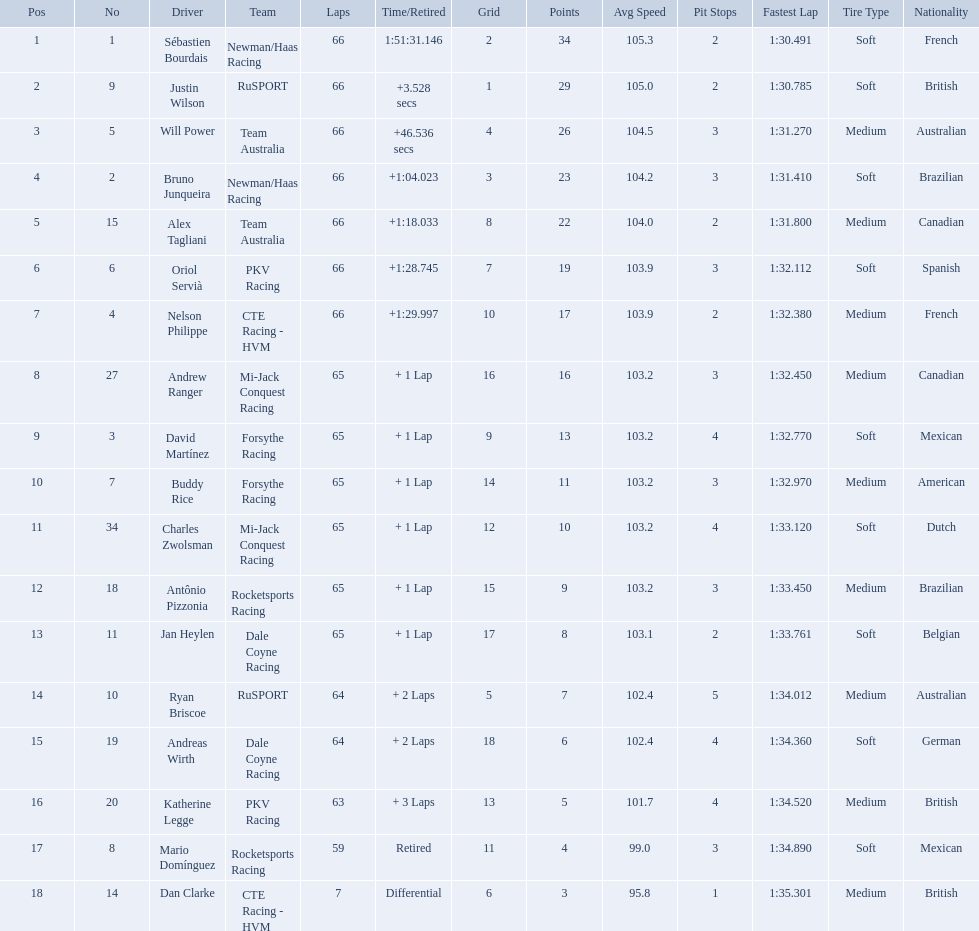What are the names of the drivers who were in position 14 through position 18? Ryan Briscoe, Andreas Wirth, Katherine Legge, Mario Domínguez, Dan Clarke. Of these , which ones didn't finish due to retired or differential? Mario Domínguez, Dan Clarke. Which one of the previous drivers retired? Mario Domínguez. Which of the drivers in question 2 had a differential? Dan Clarke. How many laps did oriol servia complete at the 2006 gran premio? 66. How many laps did katherine legge complete at the 2006 gran premio? 63. Between servia and legge, who completed more laps? Oriol Servià. Which people scored 29+ points? Sébastien Bourdais, Justin Wilson. Who scored higher? Sébastien Bourdais. What are the drivers numbers? 1, 9, 5, 2, 15, 6, 4, 27, 3, 7, 34, 18, 11, 10, 19, 20, 8, 14. Are there any who's number matches his position? Sébastien Bourdais, Oriol Servià. Of those two who has the highest position? Sébastien Bourdais. Who are the drivers? Sébastien Bourdais, Justin Wilson, Will Power, Bruno Junqueira, Alex Tagliani, Oriol Servià, Nelson Philippe, Andrew Ranger, David Martínez, Buddy Rice, Charles Zwolsman, Antônio Pizzonia, Jan Heylen, Ryan Briscoe, Andreas Wirth, Katherine Legge, Mario Domínguez, Dan Clarke. What are their numbers? 1, 9, 5, 2, 15, 6, 4, 27, 3, 7, 34, 18, 11, 10, 19, 20, 8, 14. What are their positions? 1, 2, 3, 4, 5, 6, 7, 8, 9, 10, 11, 12, 13, 14, 15, 16, 17, 18. Which driver has the same number and position? Sébastien Bourdais. 